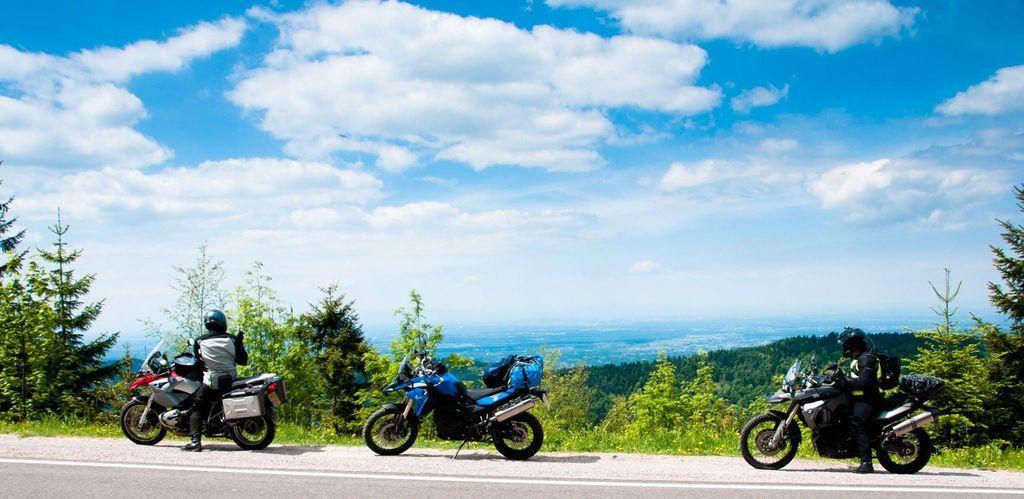Please provide a concise description of this image. In this picture there are bikes and trees at the bottom side of the image and there is sky at the top side of the image. 